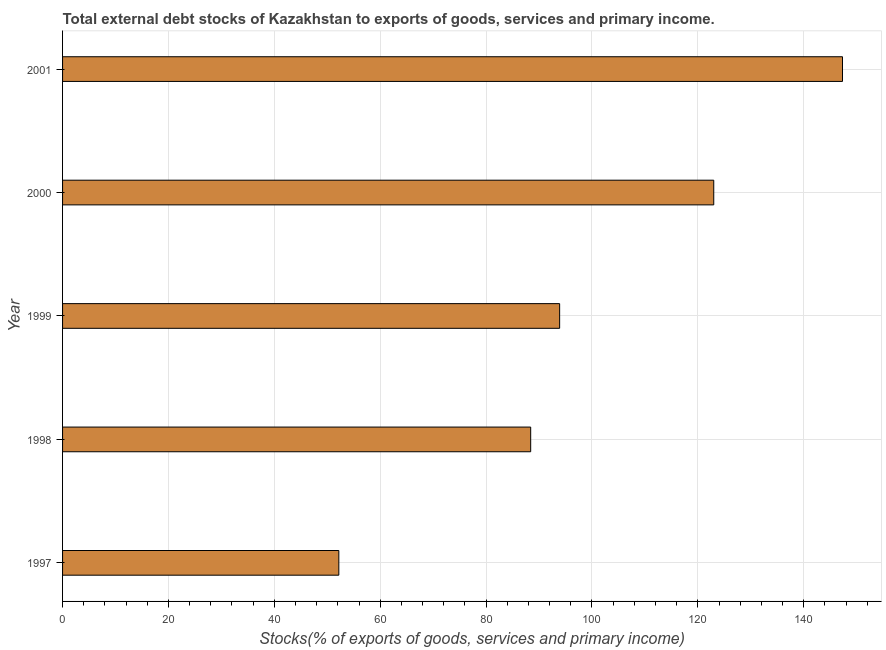What is the title of the graph?
Provide a short and direct response. Total external debt stocks of Kazakhstan to exports of goods, services and primary income. What is the label or title of the X-axis?
Provide a succinct answer. Stocks(% of exports of goods, services and primary income). What is the external debt stocks in 2000?
Offer a terse response. 123. Across all years, what is the maximum external debt stocks?
Keep it short and to the point. 147.32. Across all years, what is the minimum external debt stocks?
Your answer should be compact. 52.18. In which year was the external debt stocks minimum?
Ensure brevity in your answer.  1997. What is the sum of the external debt stocks?
Offer a very short reply. 504.81. What is the difference between the external debt stocks in 1998 and 1999?
Provide a short and direct response. -5.47. What is the average external debt stocks per year?
Ensure brevity in your answer.  100.96. What is the median external debt stocks?
Provide a succinct answer. 93.89. Do a majority of the years between 1999 and 1997 (inclusive) have external debt stocks greater than 36 %?
Provide a succinct answer. Yes. What is the ratio of the external debt stocks in 1998 to that in 2000?
Provide a short and direct response. 0.72. What is the difference between the highest and the second highest external debt stocks?
Your answer should be very brief. 24.32. What is the difference between the highest and the lowest external debt stocks?
Provide a short and direct response. 95.14. Are all the bars in the graph horizontal?
Your response must be concise. Yes. How many years are there in the graph?
Your response must be concise. 5. What is the difference between two consecutive major ticks on the X-axis?
Offer a terse response. 20. What is the Stocks(% of exports of goods, services and primary income) in 1997?
Offer a very short reply. 52.18. What is the Stocks(% of exports of goods, services and primary income) in 1998?
Ensure brevity in your answer.  88.42. What is the Stocks(% of exports of goods, services and primary income) of 1999?
Make the answer very short. 93.89. What is the Stocks(% of exports of goods, services and primary income) of 2000?
Keep it short and to the point. 123. What is the Stocks(% of exports of goods, services and primary income) in 2001?
Your answer should be very brief. 147.32. What is the difference between the Stocks(% of exports of goods, services and primary income) in 1997 and 1998?
Offer a very short reply. -36.24. What is the difference between the Stocks(% of exports of goods, services and primary income) in 1997 and 1999?
Your answer should be compact. -41.71. What is the difference between the Stocks(% of exports of goods, services and primary income) in 1997 and 2000?
Offer a terse response. -70.82. What is the difference between the Stocks(% of exports of goods, services and primary income) in 1997 and 2001?
Provide a succinct answer. -95.14. What is the difference between the Stocks(% of exports of goods, services and primary income) in 1998 and 1999?
Offer a very short reply. -5.47. What is the difference between the Stocks(% of exports of goods, services and primary income) in 1998 and 2000?
Provide a succinct answer. -34.58. What is the difference between the Stocks(% of exports of goods, services and primary income) in 1998 and 2001?
Offer a terse response. -58.9. What is the difference between the Stocks(% of exports of goods, services and primary income) in 1999 and 2000?
Offer a very short reply. -29.11. What is the difference between the Stocks(% of exports of goods, services and primary income) in 1999 and 2001?
Offer a terse response. -53.43. What is the difference between the Stocks(% of exports of goods, services and primary income) in 2000 and 2001?
Make the answer very short. -24.32. What is the ratio of the Stocks(% of exports of goods, services and primary income) in 1997 to that in 1998?
Provide a short and direct response. 0.59. What is the ratio of the Stocks(% of exports of goods, services and primary income) in 1997 to that in 1999?
Make the answer very short. 0.56. What is the ratio of the Stocks(% of exports of goods, services and primary income) in 1997 to that in 2000?
Your answer should be very brief. 0.42. What is the ratio of the Stocks(% of exports of goods, services and primary income) in 1997 to that in 2001?
Make the answer very short. 0.35. What is the ratio of the Stocks(% of exports of goods, services and primary income) in 1998 to that in 1999?
Offer a very short reply. 0.94. What is the ratio of the Stocks(% of exports of goods, services and primary income) in 1998 to that in 2000?
Your response must be concise. 0.72. What is the ratio of the Stocks(% of exports of goods, services and primary income) in 1999 to that in 2000?
Ensure brevity in your answer.  0.76. What is the ratio of the Stocks(% of exports of goods, services and primary income) in 1999 to that in 2001?
Ensure brevity in your answer.  0.64. What is the ratio of the Stocks(% of exports of goods, services and primary income) in 2000 to that in 2001?
Provide a short and direct response. 0.83. 